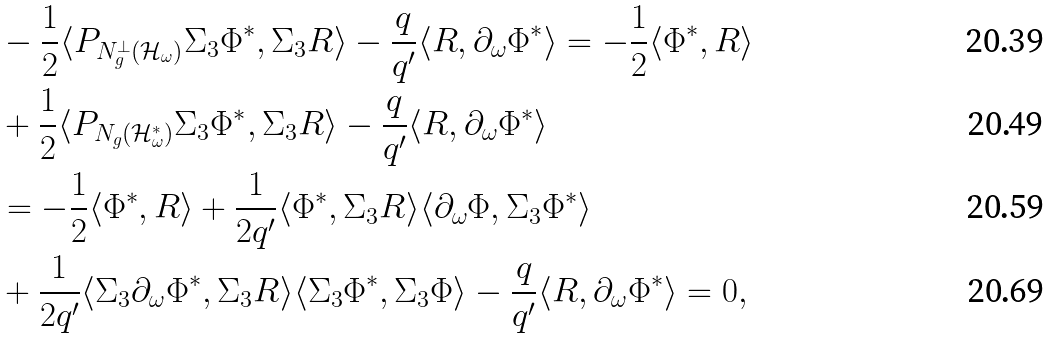Convert formula to latex. <formula><loc_0><loc_0><loc_500><loc_500>& - \frac { 1 } { 2 } \langle P _ { N ^ { \perp } _ { g } ( \mathcal { H } _ { \omega } ) } \Sigma _ { 3 } \Phi ^ { * } , \Sigma _ { 3 } R \rangle - \frac { q } { q ^ { \prime } } \langle R , \partial _ { \omega } \Phi ^ { * } \rangle = - \frac { 1 } { 2 } \langle \Phi ^ { * } , R \rangle \\ & + \frac { 1 } { 2 } \langle P _ { N _ { g } ( \mathcal { H } _ { \omega } ^ { * } ) } \Sigma _ { 3 } \Phi ^ { * } , \Sigma _ { 3 } R \rangle - \frac { q } { q ^ { \prime } } \langle R , \partial _ { \omega } \Phi ^ { * } \rangle \\ & = - \frac { 1 } { 2 } \langle \Phi ^ { * } , R \rangle + \frac { 1 } { 2 q ^ { \prime } } \langle \Phi ^ { * } , \Sigma _ { 3 } R \rangle \langle \partial _ { \omega } \Phi , \Sigma _ { 3 } \Phi ^ { * } \rangle \\ & + \frac { 1 } { 2 q ^ { \prime } } \langle \Sigma _ { 3 } \partial _ { \omega } \Phi ^ { * } , \Sigma _ { 3 } R \rangle \langle \Sigma _ { 3 } \Phi ^ { * } , \Sigma _ { 3 } \Phi \rangle - \frac { q } { q ^ { \prime } } \langle R , \partial _ { \omega } \Phi ^ { * } \rangle = 0 ,</formula> 